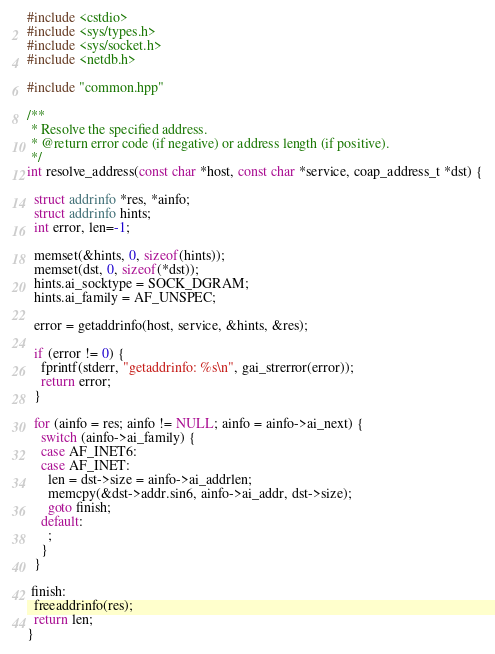<code> <loc_0><loc_0><loc_500><loc_500><_C++_>#include <cstdio>
#include <sys/types.h>
#include <sys/socket.h>
#include <netdb.h>

#include "common.hpp"

/**
 * Resolve the specified address.
 * @return error code (if negative) or address length (if positive).
 */
int resolve_address(const char *host, const char *service, coap_address_t *dst) {

  struct addrinfo *res, *ainfo;
  struct addrinfo hints;
  int error, len=-1;

  memset(&hints, 0, sizeof(hints));
  memset(dst, 0, sizeof(*dst));
  hints.ai_socktype = SOCK_DGRAM;
  hints.ai_family = AF_UNSPEC;

  error = getaddrinfo(host, service, &hints, &res);

  if (error != 0) {
    fprintf(stderr, "getaddrinfo: %s\n", gai_strerror(error));
    return error;
  }

  for (ainfo = res; ainfo != NULL; ainfo = ainfo->ai_next) {
    switch (ainfo->ai_family) {
    case AF_INET6:
    case AF_INET:
      len = dst->size = ainfo->ai_addrlen;
      memcpy(&dst->addr.sin6, ainfo->ai_addr, dst->size);
      goto finish;
    default:
      ;
    }
  }

 finish:
  freeaddrinfo(res);
  return len;
}

</code> 